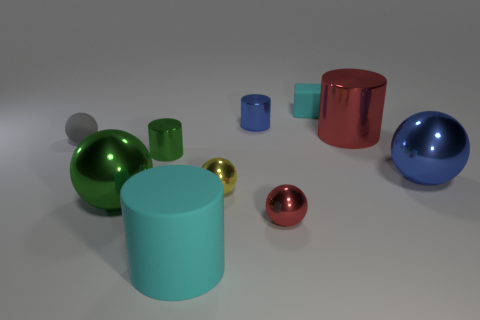Can you describe the arrangement and colors of the objects in this image? Certainly! The arrangement of objects in the image is aesthetically balanced, with items of various shapes and colors distributed evenly across the frame. Starting from the left, we see a large teal rubber cylinder followed by a shiny green metallic sphere. Nearby, a tiny gold sphere sits in the foreground, while a small cyan cylinder and a reflective red cube are seen in the background. Towards the right, there's a large metallic sphere with a vibrant blue hue accompanied by a small blue metallic cylinder, and to the far right is a shiny red cylindrical container. The colors range from cool tones like teal and blue to warm tones like red and gold, creating a visually harmonious scene. 